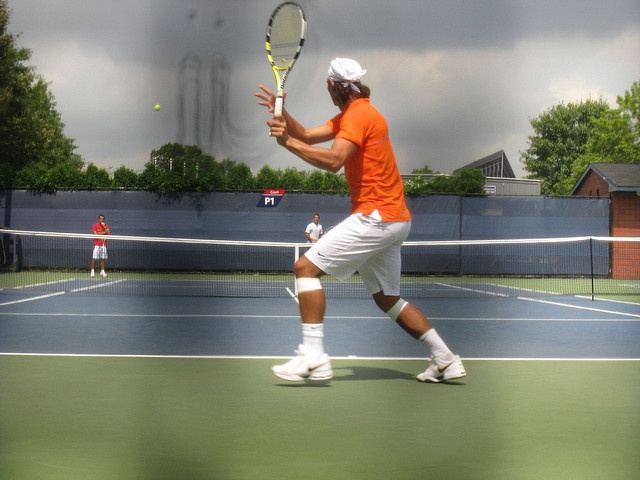Describe the objects in this image and their specific colors. I can see people in gray, white, red, and darkgray tones, tennis racket in gray, darkgray, and ivory tones, people in gray, lightgray, brown, and darkgray tones, people in gray, lightgray, and darkgray tones, and tennis racket in gray, darkgray, lightgray, and maroon tones in this image. 